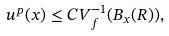Convert formula to latex. <formula><loc_0><loc_0><loc_500><loc_500>u ^ { p } ( x ) \leq C V ^ { - 1 } _ { f } ( B _ { x } ( R ) ) ,</formula> 